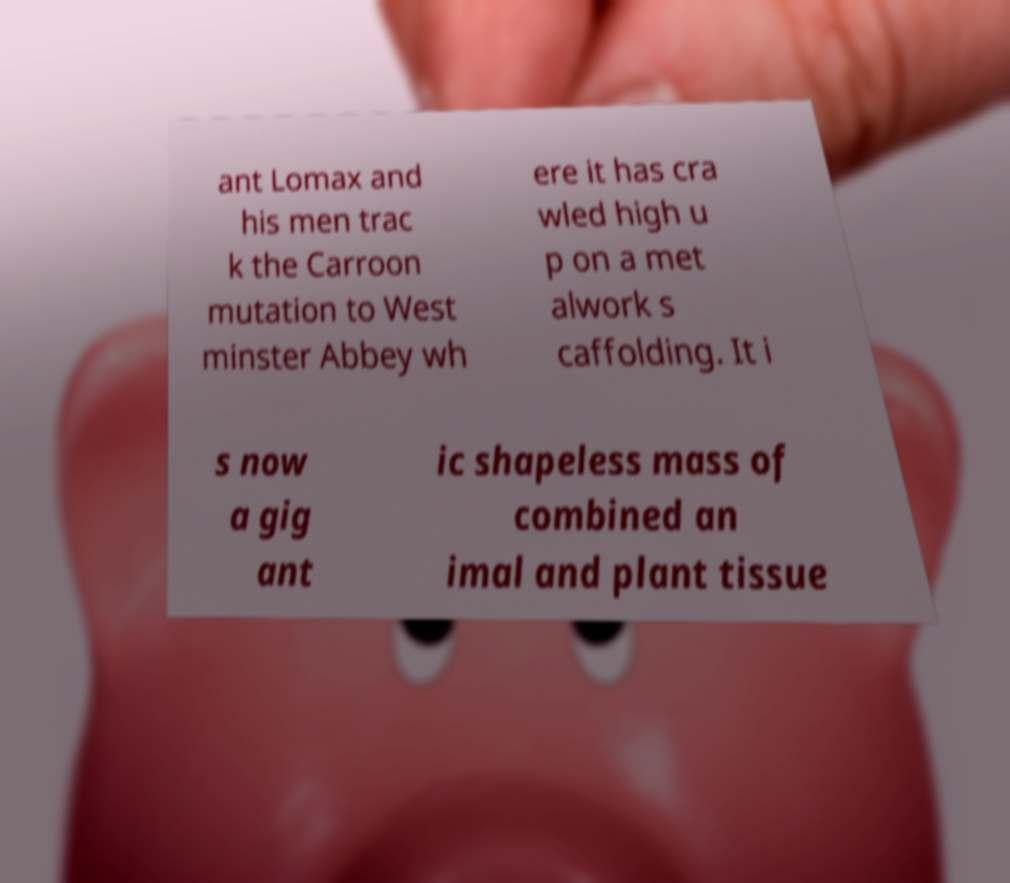I need the written content from this picture converted into text. Can you do that? ant Lomax and his men trac k the Carroon mutation to West minster Abbey wh ere it has cra wled high u p on a met alwork s caffolding. It i s now a gig ant ic shapeless mass of combined an imal and plant tissue 